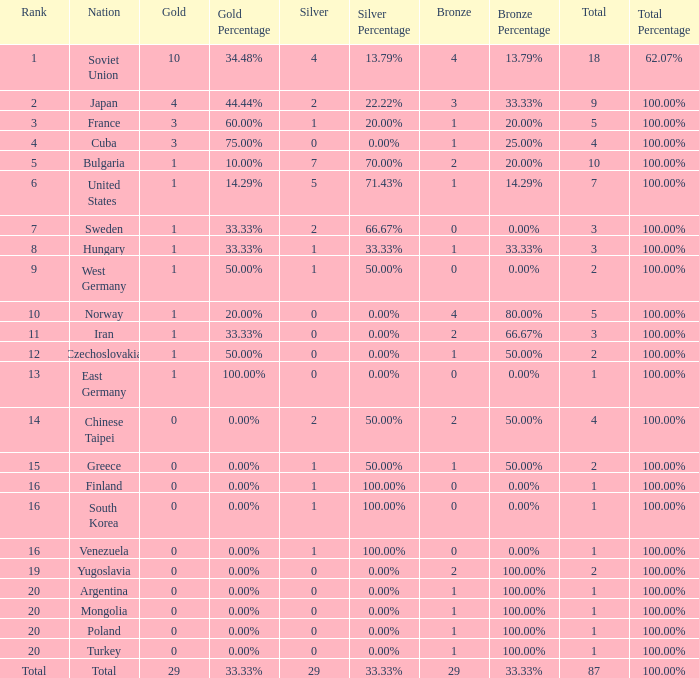What is the average number of bronze medals for total of all nations? 29.0. 